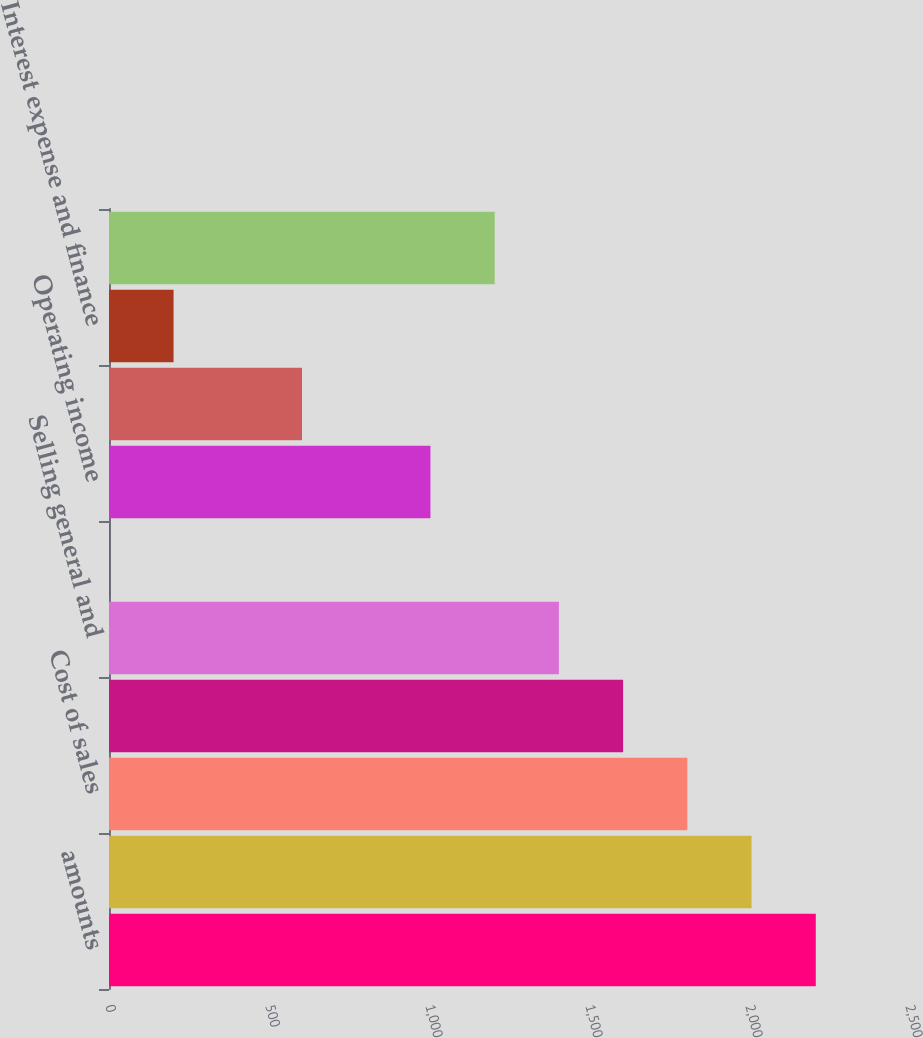Convert chart to OTSL. <chart><loc_0><loc_0><loc_500><loc_500><bar_chart><fcel>amounts<fcel>Net sales<fcel>Cost of sales<fcel>Gross profit<fcel>Selling general and<fcel>Other (income) expense<fcel>Operating income<fcel>Equity in affiliate earnings<fcel>Interest expense and finance<fcel>Income before income taxes and<nl><fcel>2208.69<fcel>2008<fcel>1807.31<fcel>1606.62<fcel>1405.93<fcel>1.1<fcel>1004.55<fcel>603.17<fcel>201.79<fcel>1205.24<nl></chart> 